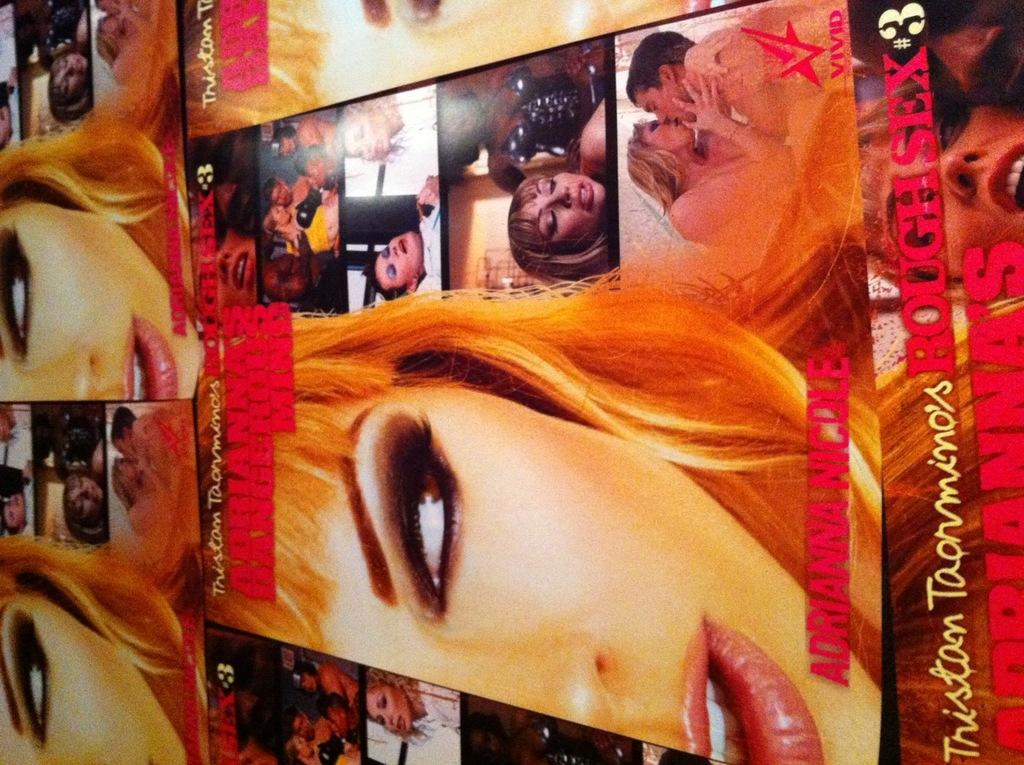<image>
Provide a brief description of the given image. A magazine with a woman's face on it that says Adrianna Nicole on the bottom of it. 